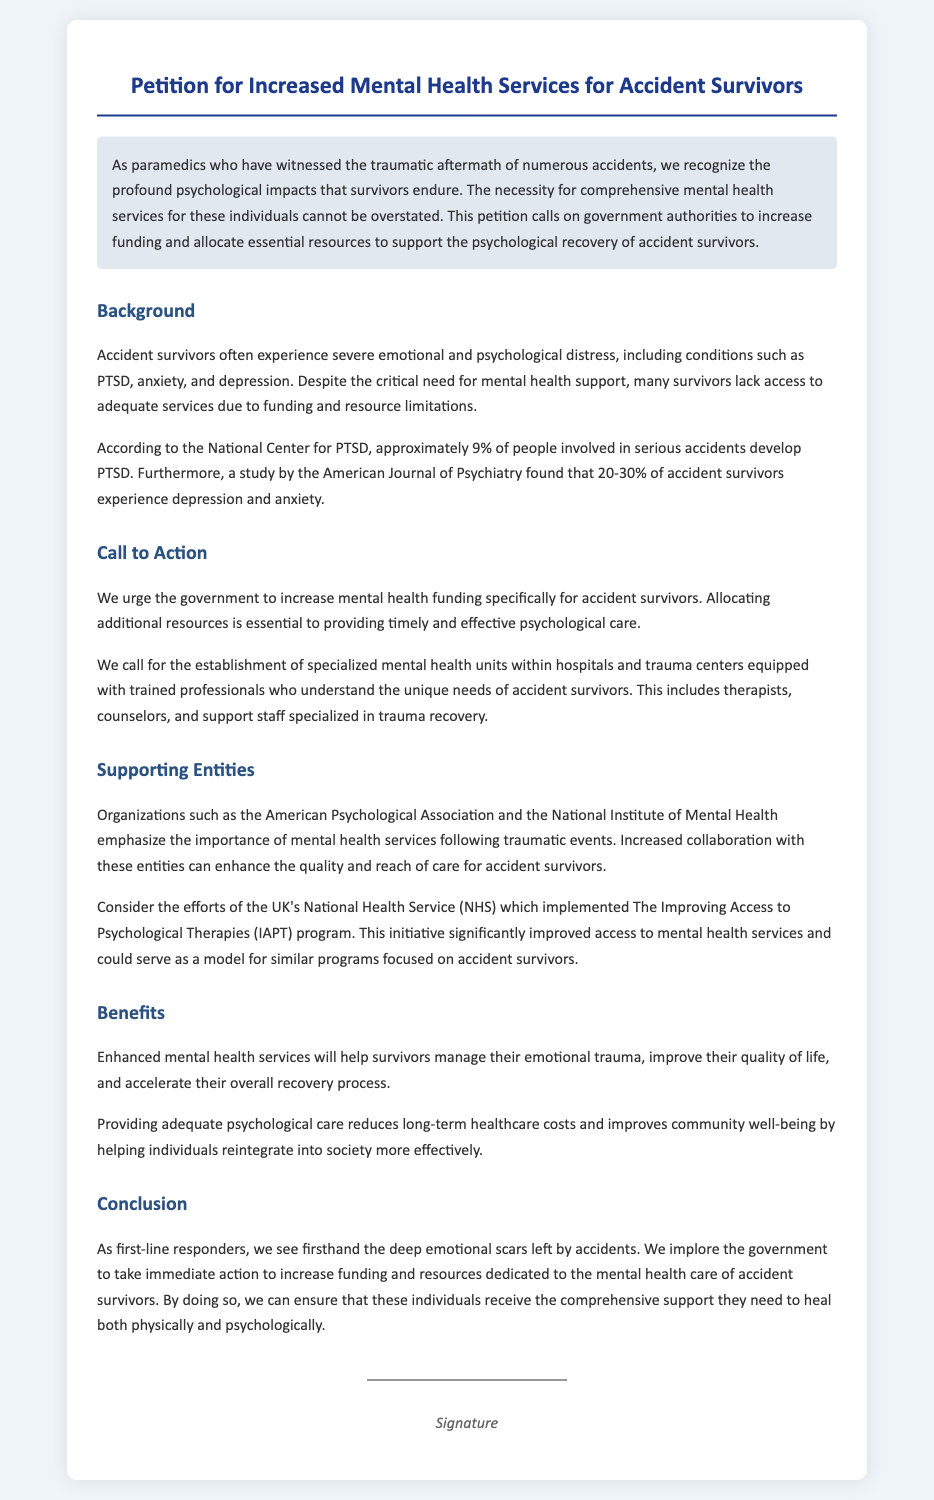What is the title of the petition? The title is explicitly stated at the beginning of the document.
Answer: Petition for Increased Mental Health Services for Accident Survivors What percentage of people involved in serious accidents develop PTSD? This information is provided in the background section of the document.
Answer: 9% Which organizations support the call for increased mental health services? The document lists organizations that emphasize the importance of mental health services.
Answer: American Psychological Association and National Institute of Mental Health What is recommended to be established within hospitals and trauma centers? The document mentions specific recommendations made in the call to action section.
Answer: Specialized mental health units What program does the document mention as a successful model for mental health services? This program is highlighted to demonstrate effective implementation of mental health services.
Answer: Improving Access to Psychological Therapies (IAPT) What is the primary focus of this petition? The main focus of the petition is stated clearly in the introduction.
Answer: Support psychological recovery of accident survivors What is the conclusion's main appeal to the government? The conclusion summarizes the urgent request to the government.
Answer: Increase funding and resources What benefit does enhanced mental health services provide to community well-being? The document explains one of the benefits of adequate psychological care.
Answer: Improves community well-being 